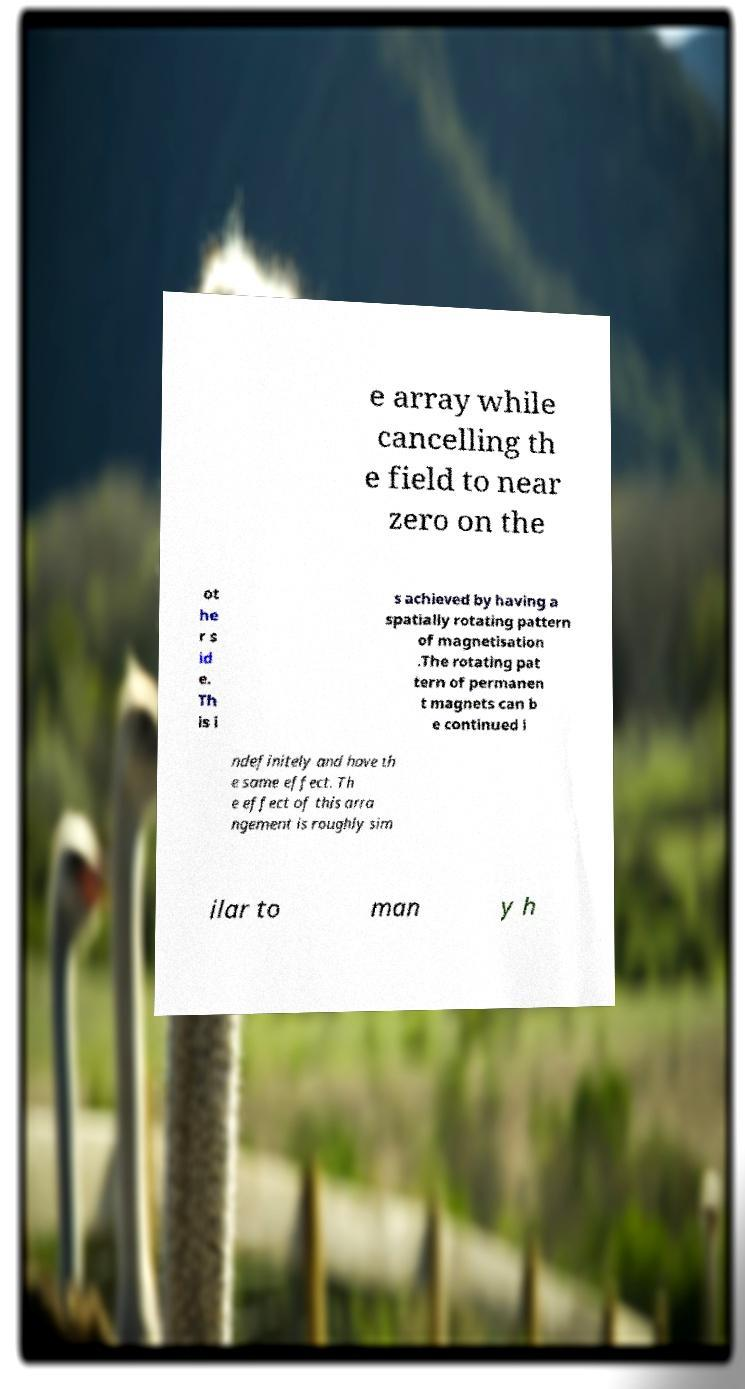Please identify and transcribe the text found in this image. e array while cancelling th e field to near zero on the ot he r s id e. Th is i s achieved by having a spatially rotating pattern of magnetisation .The rotating pat tern of permanen t magnets can b e continued i ndefinitely and have th e same effect. Th e effect of this arra ngement is roughly sim ilar to man y h 